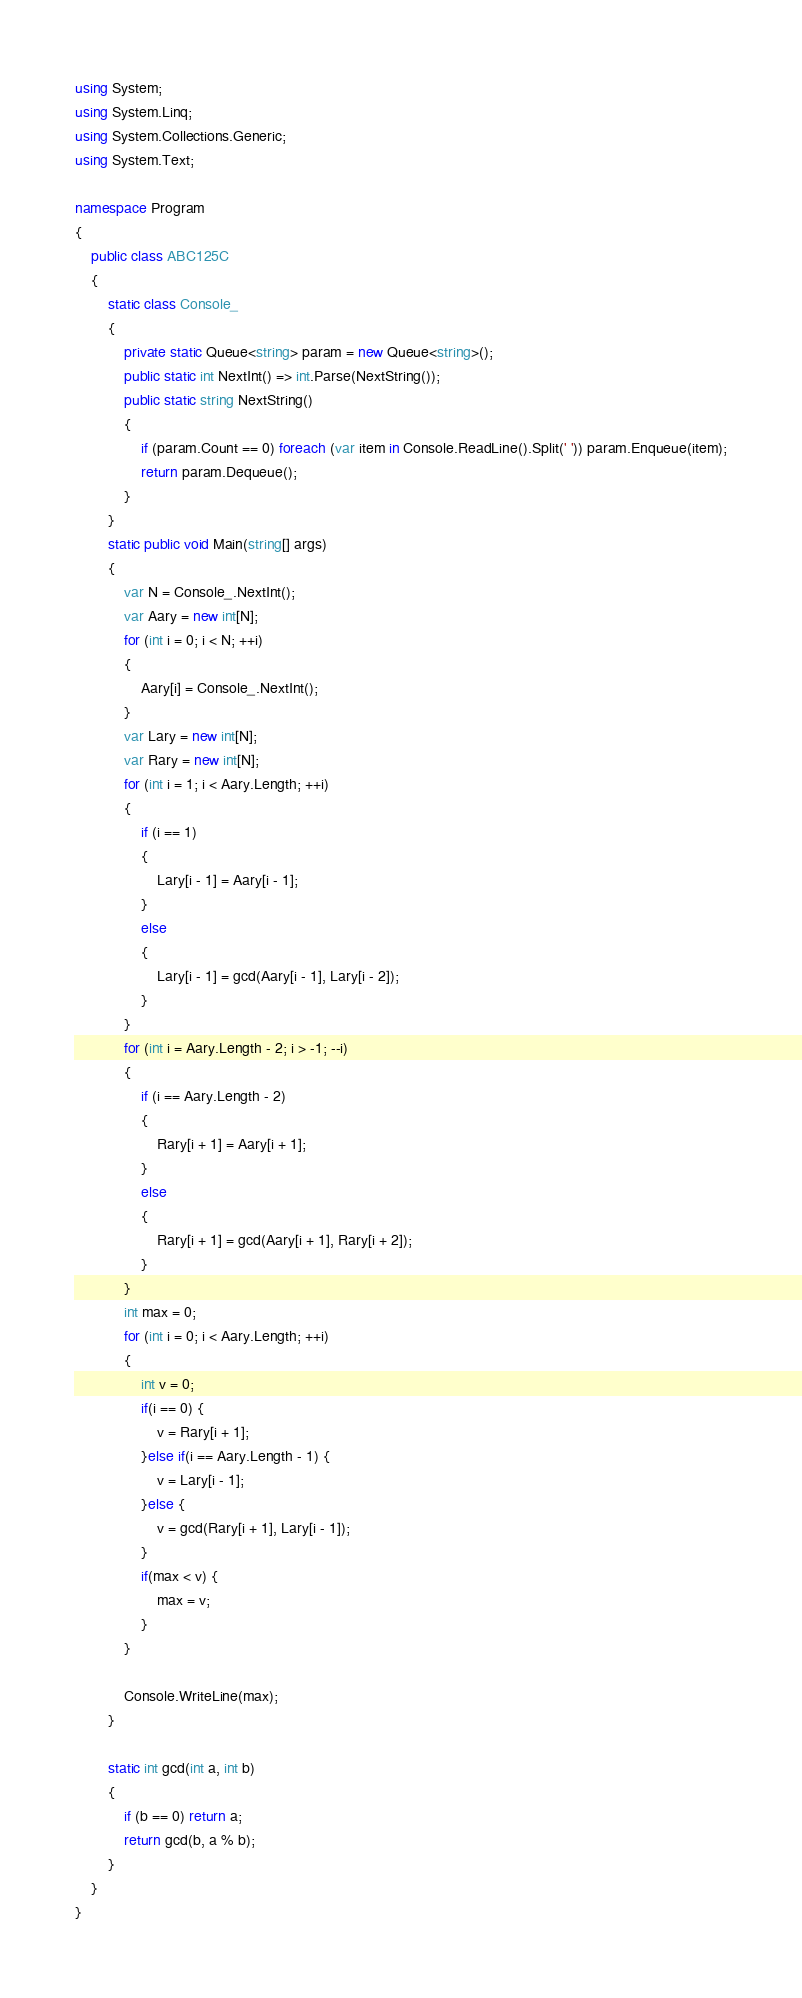Convert code to text. <code><loc_0><loc_0><loc_500><loc_500><_C#_>using System;
using System.Linq;
using System.Collections.Generic;
using System.Text;

namespace Program
{
    public class ABC125C
    {
        static class Console_
        {
            private static Queue<string> param = new Queue<string>();
            public static int NextInt() => int.Parse(NextString());
            public static string NextString()
            {
                if (param.Count == 0) foreach (var item in Console.ReadLine().Split(' ')) param.Enqueue(item);
                return param.Dequeue();
            }
        }
        static public void Main(string[] args)
        {
            var N = Console_.NextInt();
            var Aary = new int[N];
            for (int i = 0; i < N; ++i)
            {
                Aary[i] = Console_.NextInt();
            }
            var Lary = new int[N];
            var Rary = new int[N];
            for (int i = 1; i < Aary.Length; ++i)
            {
                if (i == 1)
                {
                    Lary[i - 1] = Aary[i - 1];
                }
                else
                {
                    Lary[i - 1] = gcd(Aary[i - 1], Lary[i - 2]);
                }
            }
            for (int i = Aary.Length - 2; i > -1; --i)
            {
                if (i == Aary.Length - 2)
                {
                    Rary[i + 1] = Aary[i + 1];
                }
                else
                {
                    Rary[i + 1] = gcd(Aary[i + 1], Rary[i + 2]);
                }
            }
            int max = 0;
            for (int i = 0; i < Aary.Length; ++i)
            {
                int v = 0;
                if(i == 0) {
                    v = Rary[i + 1];
                }else if(i == Aary.Length - 1) {
                    v = Lary[i - 1];
                }else {
                    v = gcd(Rary[i + 1], Lary[i - 1]);
                }
                if(max < v) {
                    max = v;
                }
            }
 
            Console.WriteLine(max);
        }
 
        static int gcd(int a, int b)
        {
            if (b == 0) return a;
            return gcd(b, a % b);
        }
    }
}
</code> 